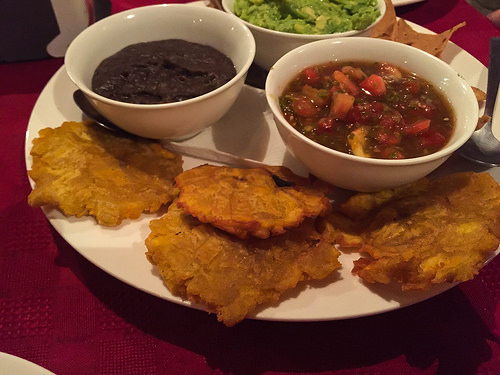<image>
Is there a food in the bowl? No. The food is not contained within the bowl. These objects have a different spatial relationship. 